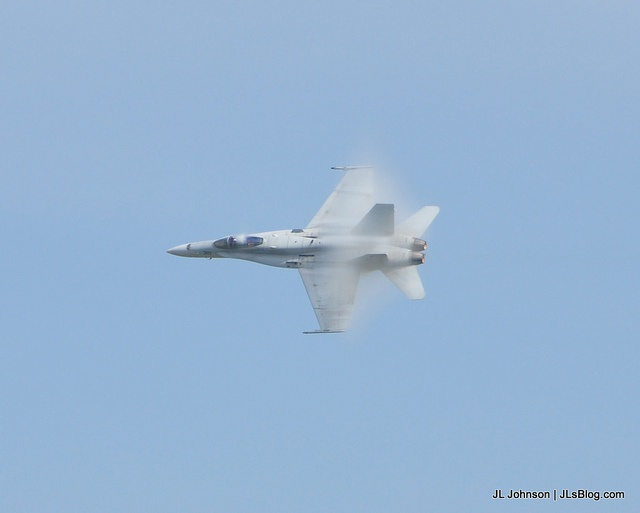Describe the objects in this image and their specific colors. I can see a airplane in lightblue, darkgray, and lightgray tones in this image. 